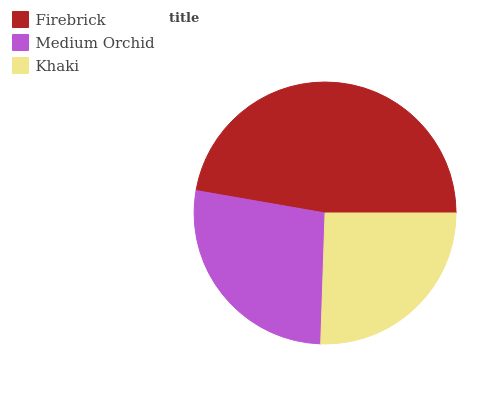Is Khaki the minimum?
Answer yes or no. Yes. Is Firebrick the maximum?
Answer yes or no. Yes. Is Medium Orchid the minimum?
Answer yes or no. No. Is Medium Orchid the maximum?
Answer yes or no. No. Is Firebrick greater than Medium Orchid?
Answer yes or no. Yes. Is Medium Orchid less than Firebrick?
Answer yes or no. Yes. Is Medium Orchid greater than Firebrick?
Answer yes or no. No. Is Firebrick less than Medium Orchid?
Answer yes or no. No. Is Medium Orchid the high median?
Answer yes or no. Yes. Is Medium Orchid the low median?
Answer yes or no. Yes. Is Khaki the high median?
Answer yes or no. No. Is Firebrick the low median?
Answer yes or no. No. 